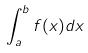Convert formula to latex. <formula><loc_0><loc_0><loc_500><loc_500>\int _ { a } ^ { b } f ( x ) d x</formula> 